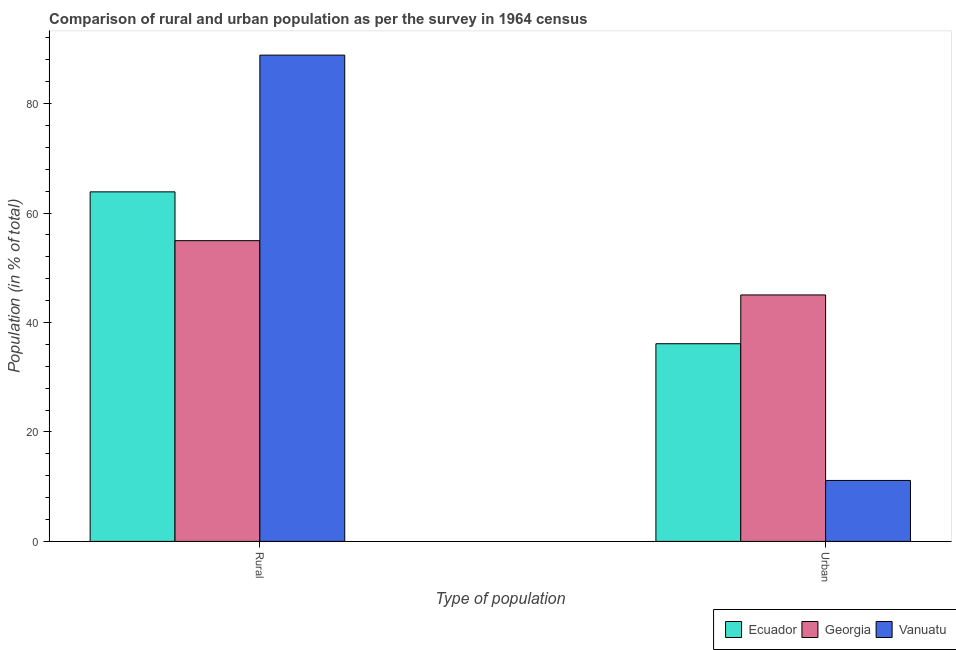How many groups of bars are there?
Provide a succinct answer. 2. How many bars are there on the 1st tick from the left?
Offer a very short reply. 3. How many bars are there on the 2nd tick from the right?
Your response must be concise. 3. What is the label of the 2nd group of bars from the left?
Provide a short and direct response. Urban. What is the urban population in Georgia?
Give a very brief answer. 45.04. Across all countries, what is the maximum rural population?
Make the answer very short. 88.86. Across all countries, what is the minimum urban population?
Your answer should be very brief. 11.14. In which country was the urban population maximum?
Offer a very short reply. Georgia. In which country was the rural population minimum?
Offer a very short reply. Georgia. What is the total rural population in the graph?
Your answer should be compact. 207.7. What is the difference between the rural population in Ecuador and that in Georgia?
Keep it short and to the point. 8.92. What is the difference between the urban population in Vanuatu and the rural population in Ecuador?
Your answer should be very brief. -52.74. What is the average rural population per country?
Your answer should be very brief. 69.23. What is the difference between the urban population and rural population in Georgia?
Keep it short and to the point. -9.92. In how many countries, is the urban population greater than 84 %?
Offer a very short reply. 0. What is the ratio of the rural population in Vanuatu to that in Ecuador?
Provide a succinct answer. 1.39. Is the urban population in Georgia less than that in Ecuador?
Give a very brief answer. No. In how many countries, is the rural population greater than the average rural population taken over all countries?
Offer a very short reply. 1. What does the 1st bar from the left in Urban represents?
Ensure brevity in your answer.  Ecuador. What does the 3rd bar from the right in Rural represents?
Your response must be concise. Ecuador. Are all the bars in the graph horizontal?
Offer a terse response. No. Are the values on the major ticks of Y-axis written in scientific E-notation?
Your response must be concise. No. Does the graph contain any zero values?
Your answer should be very brief. No. Does the graph contain grids?
Your answer should be very brief. No. What is the title of the graph?
Your answer should be very brief. Comparison of rural and urban population as per the survey in 1964 census. What is the label or title of the X-axis?
Offer a terse response. Type of population. What is the label or title of the Y-axis?
Your response must be concise. Population (in % of total). What is the Population (in % of total) in Ecuador in Rural?
Your response must be concise. 63.88. What is the Population (in % of total) in Georgia in Rural?
Ensure brevity in your answer.  54.96. What is the Population (in % of total) in Vanuatu in Rural?
Keep it short and to the point. 88.86. What is the Population (in % of total) in Ecuador in Urban?
Keep it short and to the point. 36.12. What is the Population (in % of total) in Georgia in Urban?
Keep it short and to the point. 45.04. What is the Population (in % of total) in Vanuatu in Urban?
Give a very brief answer. 11.14. Across all Type of population, what is the maximum Population (in % of total) in Ecuador?
Keep it short and to the point. 63.88. Across all Type of population, what is the maximum Population (in % of total) in Georgia?
Offer a terse response. 54.96. Across all Type of population, what is the maximum Population (in % of total) in Vanuatu?
Offer a very short reply. 88.86. Across all Type of population, what is the minimum Population (in % of total) in Ecuador?
Ensure brevity in your answer.  36.12. Across all Type of population, what is the minimum Population (in % of total) of Georgia?
Provide a succinct answer. 45.04. Across all Type of population, what is the minimum Population (in % of total) of Vanuatu?
Your answer should be very brief. 11.14. What is the total Population (in % of total) in Ecuador in the graph?
Give a very brief answer. 100. What is the total Population (in % of total) of Georgia in the graph?
Your answer should be compact. 100. What is the total Population (in % of total) in Vanuatu in the graph?
Make the answer very short. 100. What is the difference between the Population (in % of total) of Ecuador in Rural and that in Urban?
Provide a short and direct response. 27.76. What is the difference between the Population (in % of total) of Georgia in Rural and that in Urban?
Give a very brief answer. 9.92. What is the difference between the Population (in % of total) of Vanuatu in Rural and that in Urban?
Your response must be concise. 77.72. What is the difference between the Population (in % of total) in Ecuador in Rural and the Population (in % of total) in Georgia in Urban?
Your response must be concise. 18.84. What is the difference between the Population (in % of total) of Ecuador in Rural and the Population (in % of total) of Vanuatu in Urban?
Keep it short and to the point. 52.74. What is the difference between the Population (in % of total) of Georgia in Rural and the Population (in % of total) of Vanuatu in Urban?
Your response must be concise. 43.82. What is the average Population (in % of total) of Georgia per Type of population?
Offer a very short reply. 50. What is the difference between the Population (in % of total) of Ecuador and Population (in % of total) of Georgia in Rural?
Ensure brevity in your answer.  8.92. What is the difference between the Population (in % of total) of Ecuador and Population (in % of total) of Vanuatu in Rural?
Make the answer very short. -24.98. What is the difference between the Population (in % of total) in Georgia and Population (in % of total) in Vanuatu in Rural?
Offer a very short reply. -33.9. What is the difference between the Population (in % of total) of Ecuador and Population (in % of total) of Georgia in Urban?
Ensure brevity in your answer.  -8.92. What is the difference between the Population (in % of total) of Ecuador and Population (in % of total) of Vanuatu in Urban?
Provide a succinct answer. 24.98. What is the difference between the Population (in % of total) in Georgia and Population (in % of total) in Vanuatu in Urban?
Your response must be concise. 33.9. What is the ratio of the Population (in % of total) of Ecuador in Rural to that in Urban?
Your answer should be compact. 1.77. What is the ratio of the Population (in % of total) of Georgia in Rural to that in Urban?
Your answer should be very brief. 1.22. What is the ratio of the Population (in % of total) in Vanuatu in Rural to that in Urban?
Ensure brevity in your answer.  7.98. What is the difference between the highest and the second highest Population (in % of total) in Ecuador?
Offer a very short reply. 27.76. What is the difference between the highest and the second highest Population (in % of total) of Georgia?
Offer a terse response. 9.92. What is the difference between the highest and the second highest Population (in % of total) of Vanuatu?
Make the answer very short. 77.72. What is the difference between the highest and the lowest Population (in % of total) of Ecuador?
Ensure brevity in your answer.  27.76. What is the difference between the highest and the lowest Population (in % of total) of Georgia?
Your answer should be very brief. 9.92. What is the difference between the highest and the lowest Population (in % of total) in Vanuatu?
Make the answer very short. 77.72. 